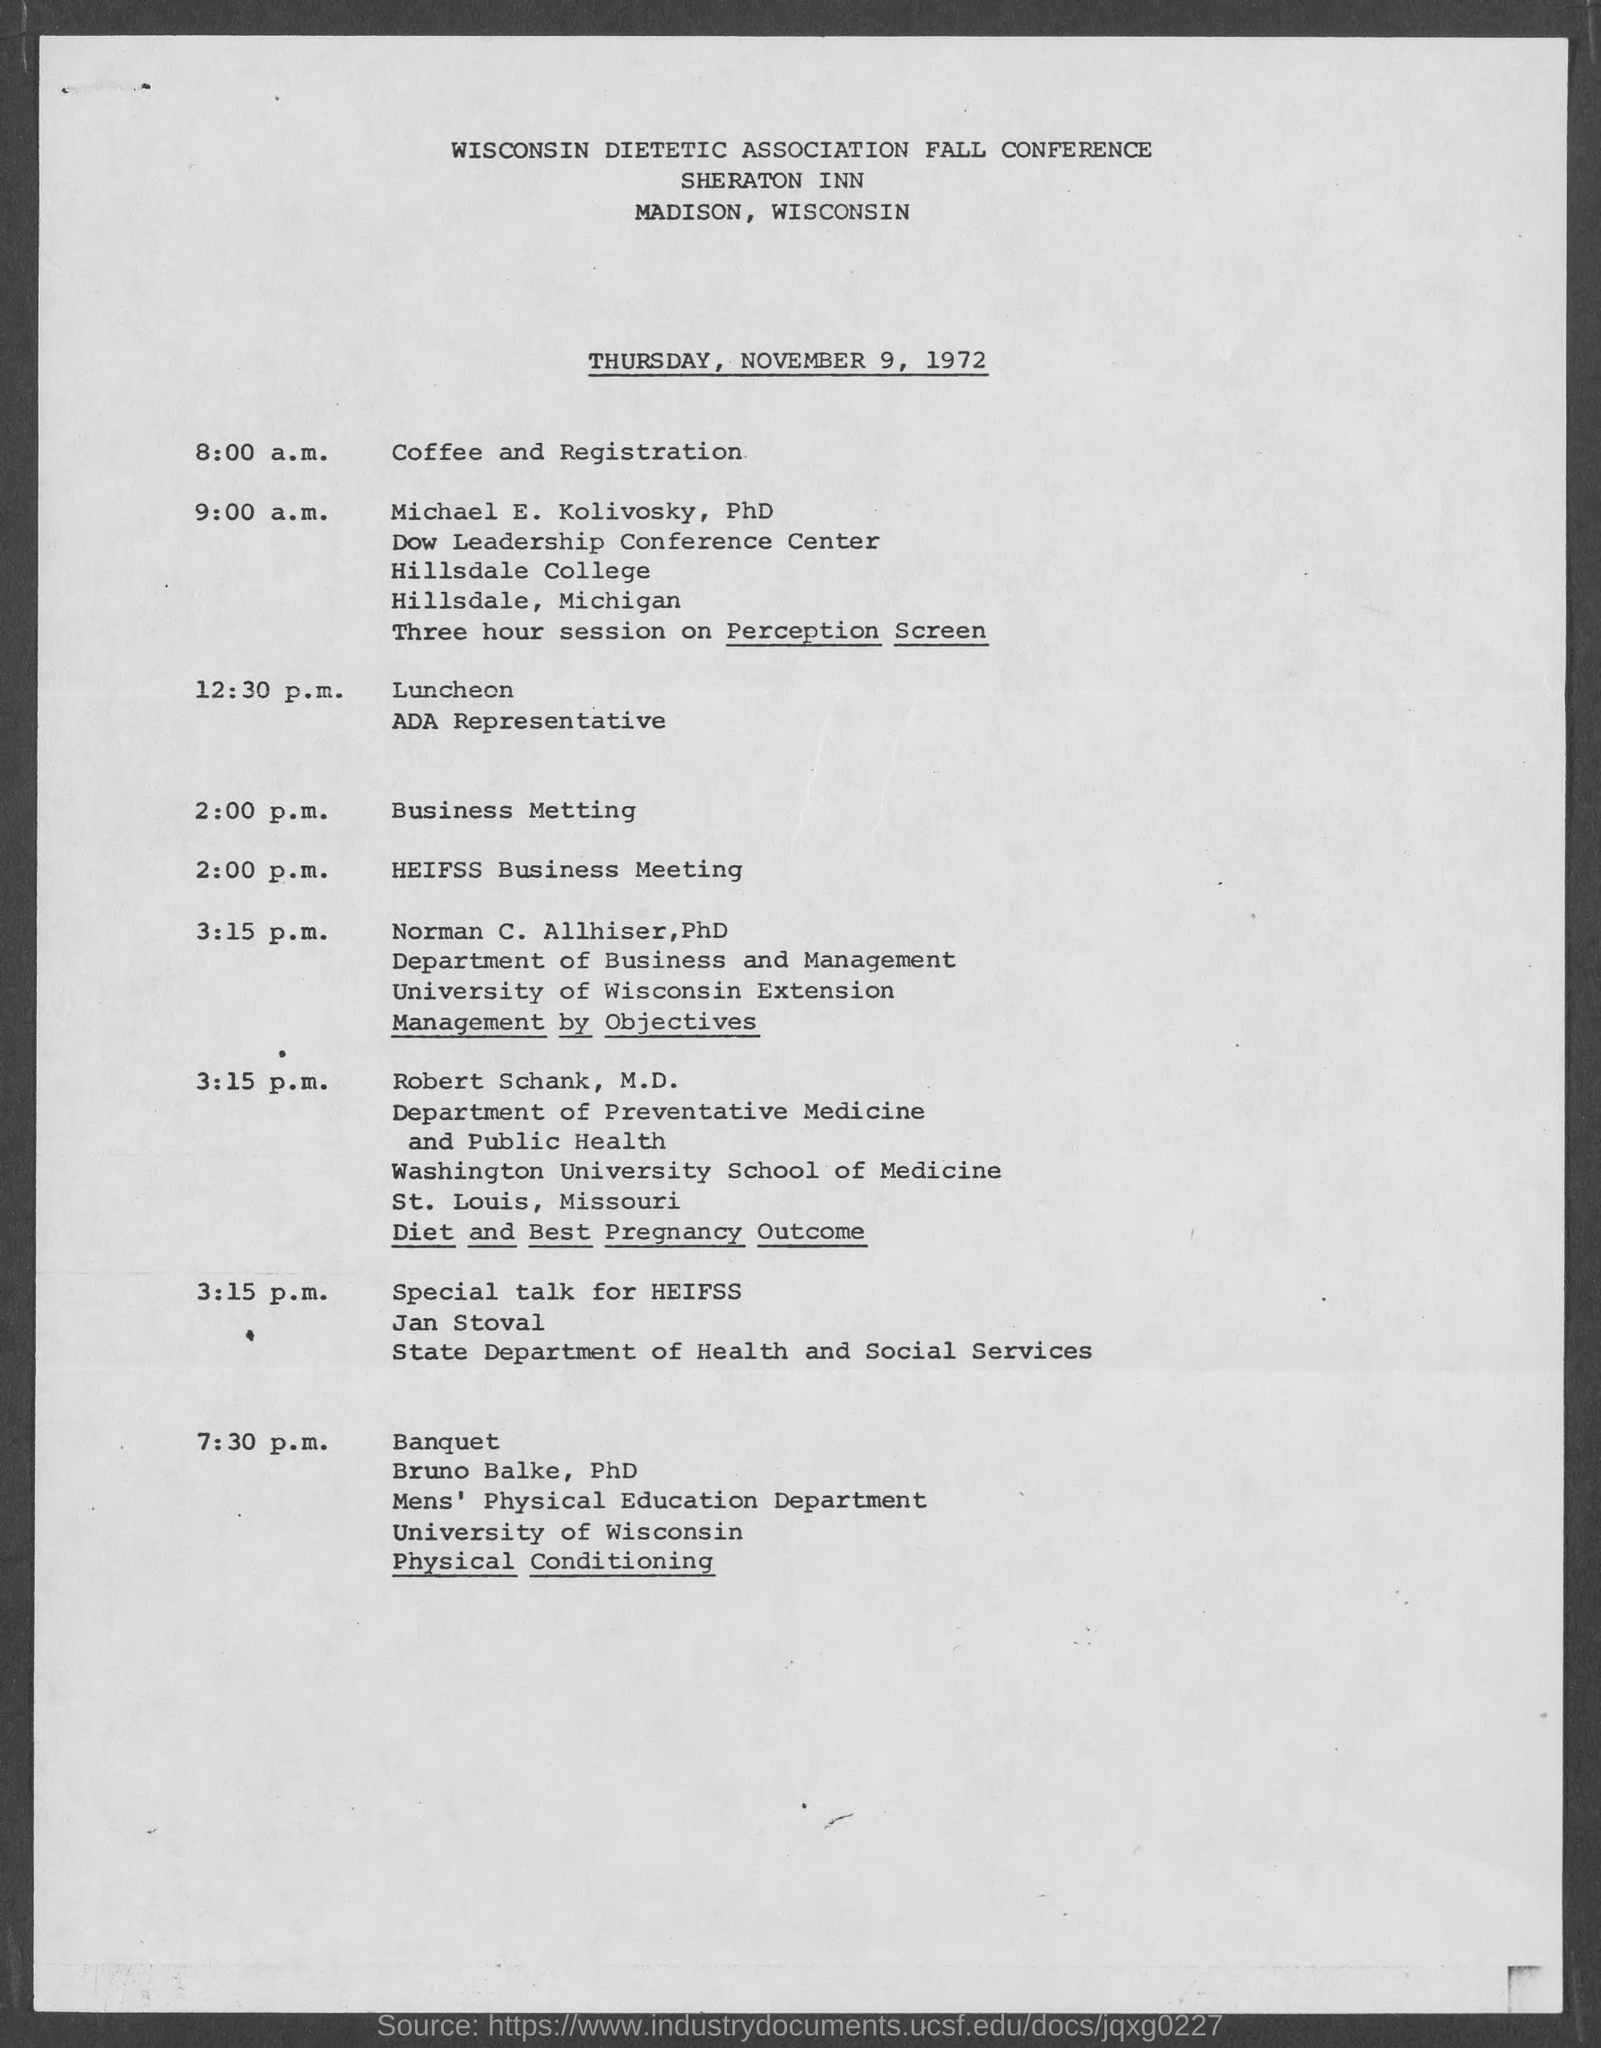When is the conference?
Offer a terse response. Thursday, November 9, 1972. 